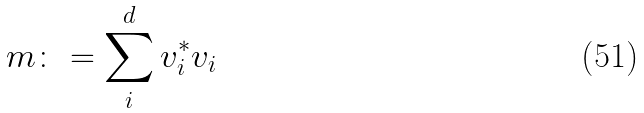Convert formula to latex. <formula><loc_0><loc_0><loc_500><loc_500>m \colon = \sum _ { i } ^ { d } v _ { i } ^ { * } v _ { i }</formula> 